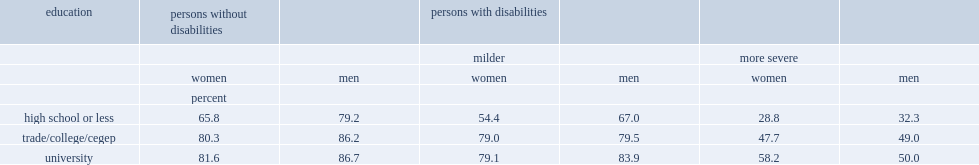Would you be able to parse every entry in this table? {'header': ['education', 'persons without disabilities', '', 'persons with disabilities', '', '', ''], 'rows': [['', '', '', 'milder', '', 'more severe', ''], ['', 'women', 'men', 'women', 'men', 'women', 'men'], ['', 'percent', '', '', '', '', ''], ['high school or less', '65.8', '79.2', '54.4', '67.0', '28.8', '32.3'], ['trade/college/cegep', '80.3', '86.2', '79.0', '79.5', '47.7', '49.0'], ['university', '81.6', '86.7', '79.1', '83.9', '58.2', '50.0']]} What are the percentages for both men and women having a trade/college certificate or cegep among those persons with more severe disabilities? 49 47.7. Among women with more severe disabilities, what percent of female with university credentials were employed, compared with half (48%) of those with college/trade credentials or cegep? 58.2. 